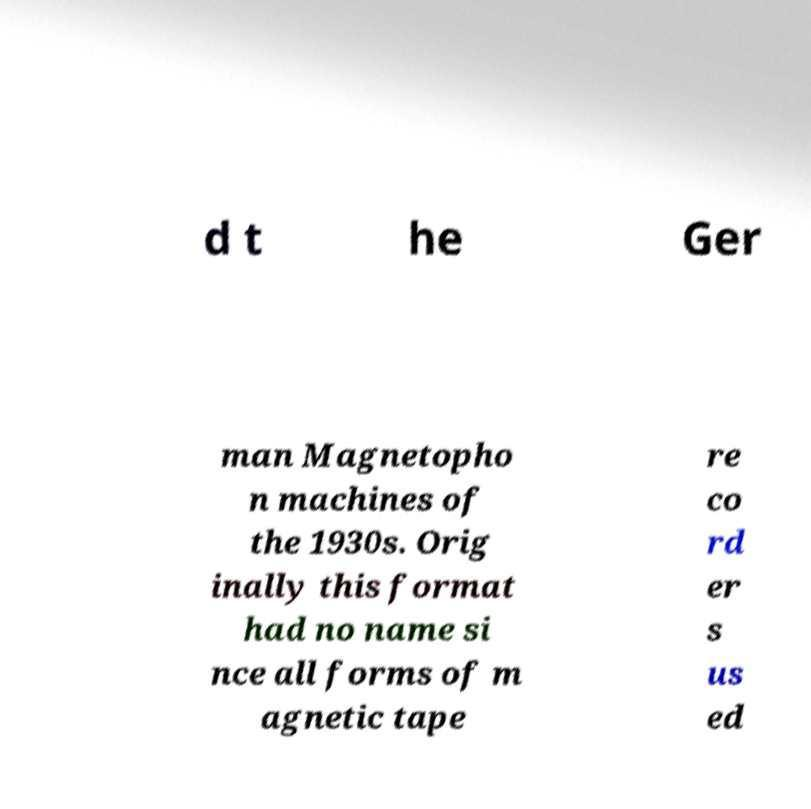What messages or text are displayed in this image? I need them in a readable, typed format. d t he Ger man Magnetopho n machines of the 1930s. Orig inally this format had no name si nce all forms of m agnetic tape re co rd er s us ed 